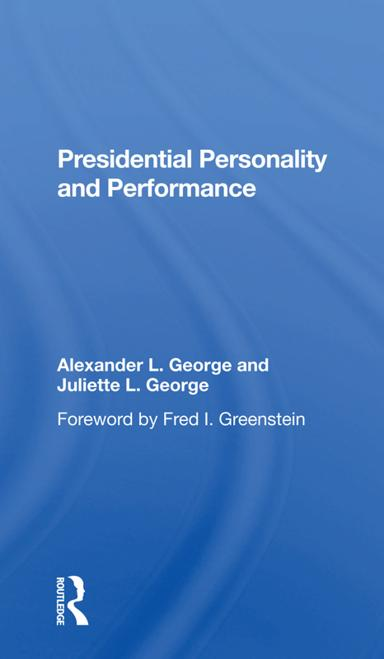How has the book 'Presidential Personality and Performance' been received by critics? The book has been well-received for its insightful analysis and unique perspective on the intersection of personality and presidential effectiveness. Critics have noted its in-depth research and thoughtful exploration of leadership traits. 